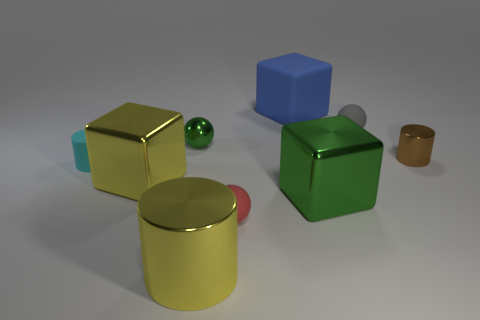What color is the small ball in front of the tiny cylinder right of the gray ball?
Provide a succinct answer. Red. How many other objects are the same material as the red sphere?
Give a very brief answer. 3. Are there an equal number of blue objects and yellow objects?
Your answer should be compact. No. How many rubber objects are either yellow objects or gray balls?
Keep it short and to the point. 1. There is another tiny rubber object that is the same shape as the gray matte thing; what color is it?
Your response must be concise. Red. How many things are either big yellow rubber objects or tiny green things?
Keep it short and to the point. 1. What is the shape of the small thing that is made of the same material as the green sphere?
Offer a terse response. Cylinder. How many big objects are either red balls or metal blocks?
Provide a short and direct response. 2. How many other things are the same color as the small rubber cylinder?
Make the answer very short. 0. There is a cylinder that is on the left side of the metal cube left of the green shiny sphere; what number of small brown metal things are on the left side of it?
Your answer should be very brief. 0. 